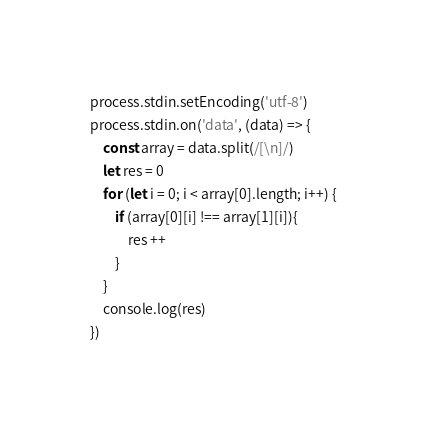Convert code to text. <code><loc_0><loc_0><loc_500><loc_500><_JavaScript_>process.stdin.setEncoding('utf-8')
process.stdin.on('data', (data) => {
    const array = data.split(/[\n]/)
    let res = 0
    for (let i = 0; i < array[0].length; i++) {
        if (array[0][i] !== array[1][i]){
            res ++
        }
    }
    console.log(res)
})
</code> 